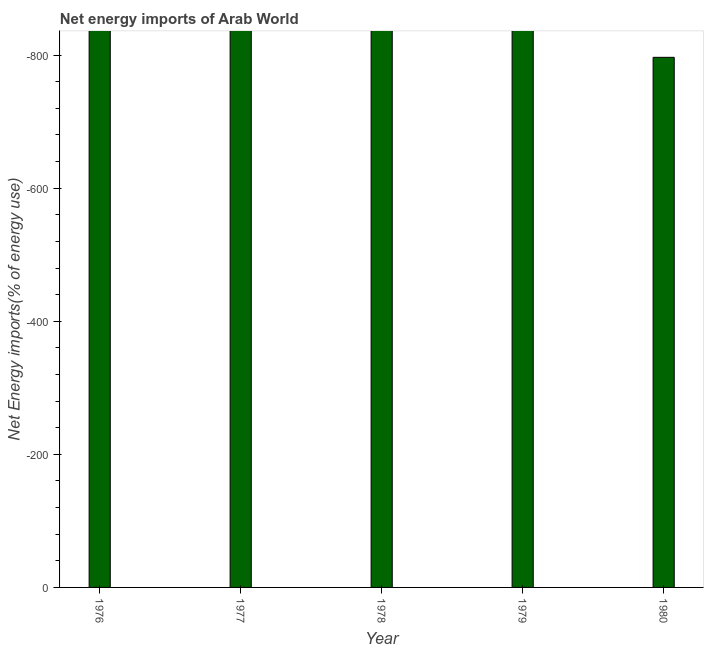Does the graph contain any zero values?
Offer a terse response. Yes. Does the graph contain grids?
Offer a very short reply. No. What is the title of the graph?
Ensure brevity in your answer.  Net energy imports of Arab World. What is the label or title of the X-axis?
Make the answer very short. Year. What is the label or title of the Y-axis?
Provide a short and direct response. Net Energy imports(% of energy use). What is the energy imports in 1979?
Your response must be concise. 0. Across all years, what is the minimum energy imports?
Your answer should be compact. 0. What is the sum of the energy imports?
Offer a very short reply. 0. What is the average energy imports per year?
Make the answer very short. 0. In how many years, is the energy imports greater than -80 %?
Ensure brevity in your answer.  0. Are all the bars in the graph horizontal?
Your response must be concise. No. How many years are there in the graph?
Ensure brevity in your answer.  5. What is the difference between two consecutive major ticks on the Y-axis?
Keep it short and to the point. 200. What is the Net Energy imports(% of energy use) in 1978?
Keep it short and to the point. 0. What is the Net Energy imports(% of energy use) of 1979?
Your answer should be very brief. 0. What is the Net Energy imports(% of energy use) of 1980?
Provide a succinct answer. 0. 